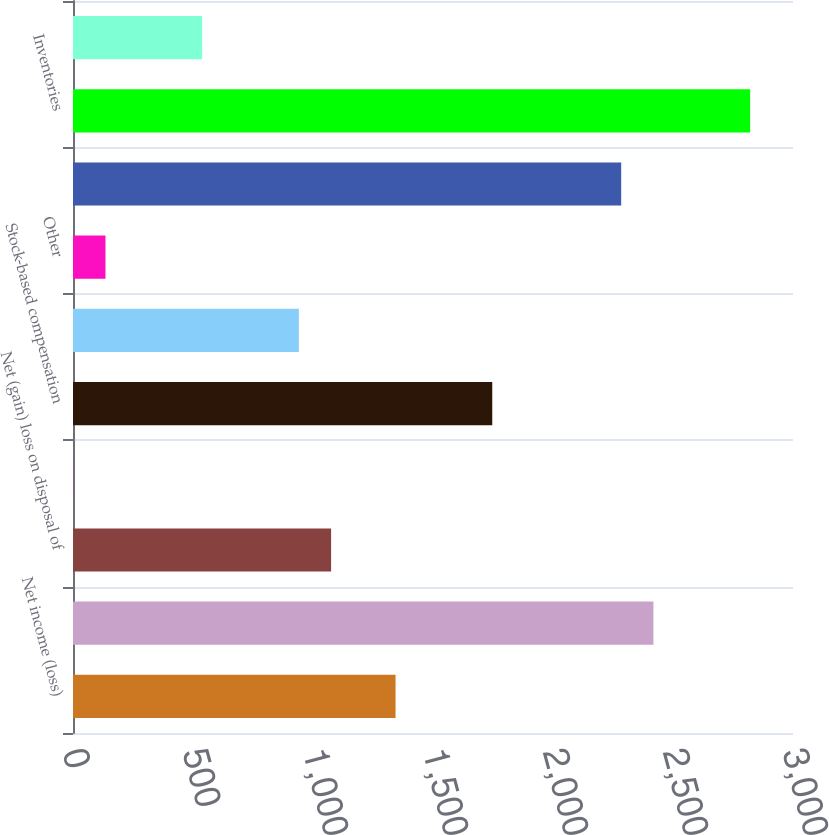<chart> <loc_0><loc_0><loc_500><loc_500><bar_chart><fcel>Net income (loss)<fcel>Depreciation and amortization<fcel>Net (gain) loss on disposal of<fcel>Deferred income taxes<fcel>Stock-based compensation<fcel>Non-cash interest expense<fcel>Other<fcel>Accounts receivable<fcel>Inventories<fcel>Prepaid expenses and other<nl><fcel>1344<fcel>2418.4<fcel>1075.4<fcel>1<fcel>1746.9<fcel>941.1<fcel>135.3<fcel>2284.1<fcel>2821.3<fcel>538.2<nl></chart> 